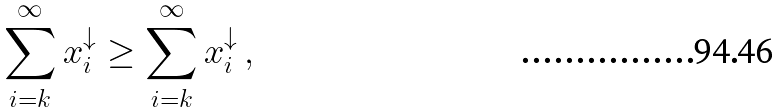Convert formula to latex. <formula><loc_0><loc_0><loc_500><loc_500>\sum _ { i = k } ^ { \infty } x ^ { \downarrow } _ { i } \geq \sum _ { i = k } ^ { \infty } x ^ { \downarrow } _ { i } \, ,</formula> 